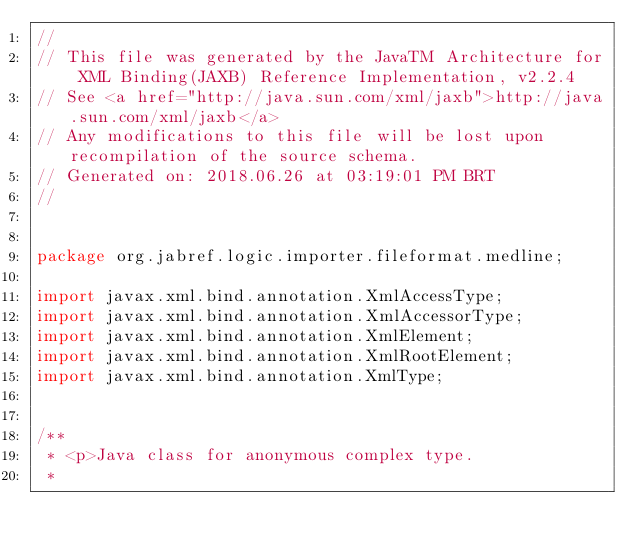Convert code to text. <code><loc_0><loc_0><loc_500><loc_500><_Java_>//
// This file was generated by the JavaTM Architecture for XML Binding(JAXB) Reference Implementation, v2.2.4 
// See <a href="http://java.sun.com/xml/jaxb">http://java.sun.com/xml/jaxb</a> 
// Any modifications to this file will be lost upon recompilation of the source schema. 
// Generated on: 2018.06.26 at 03:19:01 PM BRT 
//


package org.jabref.logic.importer.fileformat.medline;

import javax.xml.bind.annotation.XmlAccessType;
import javax.xml.bind.annotation.XmlAccessorType;
import javax.xml.bind.annotation.XmlElement;
import javax.xml.bind.annotation.XmlRootElement;
import javax.xml.bind.annotation.XmlType;


/**
 * <p>Java class for anonymous complex type.
 * </code> 